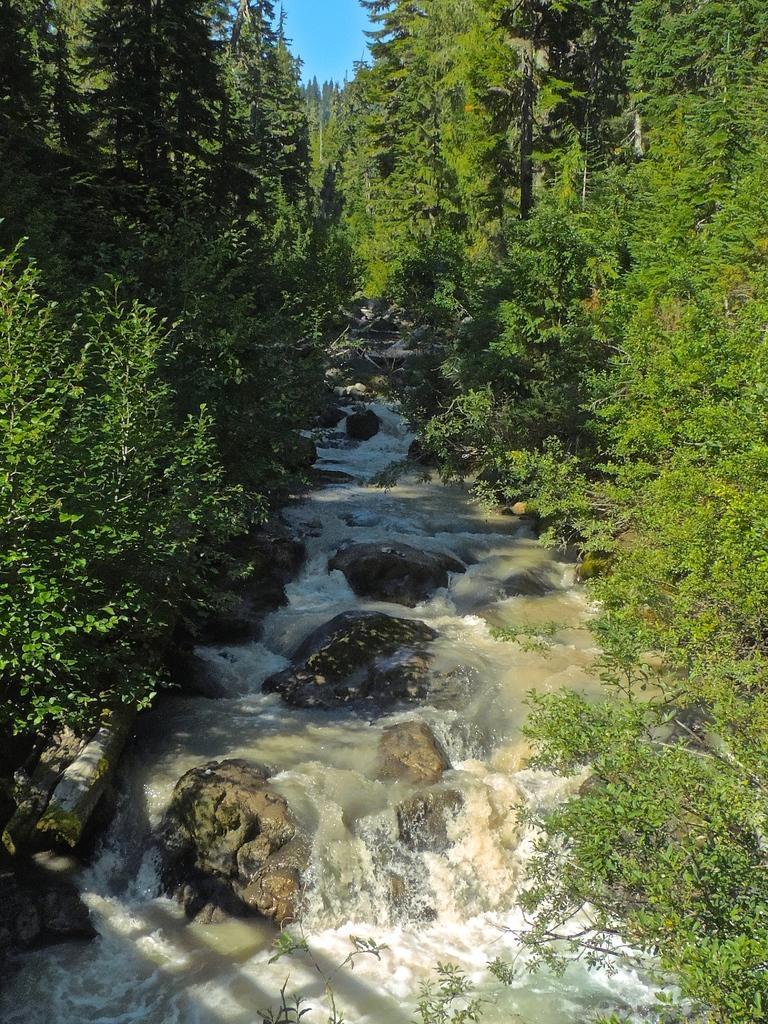Describe this image in one or two sentences. In this picture in the front there is water and there are stones. In the background there are trees. 